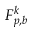Convert formula to latex. <formula><loc_0><loc_0><loc_500><loc_500>F _ { p , b } ^ { k }</formula> 